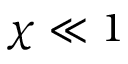Convert formula to latex. <formula><loc_0><loc_0><loc_500><loc_500>\chi \ll 1</formula> 